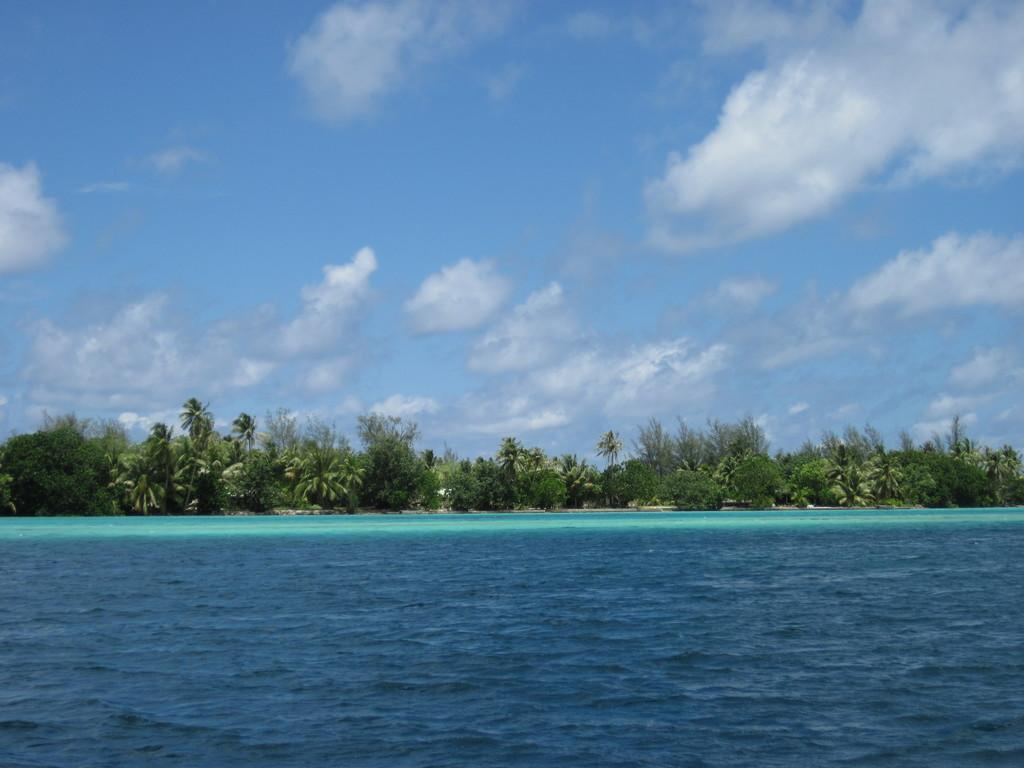What type of vegetation can be seen in the image? There are trees in the image. What natural element is visible in the image besides the trees? There is water visible in the image. What can be seen in the background of the image? The sky is visible in the background of the image. What type of car can be seen driving through the trees in the image? There is no car present in the image; it only features trees and water. Is there a bear visible in the image? There is no bear present in the image. 